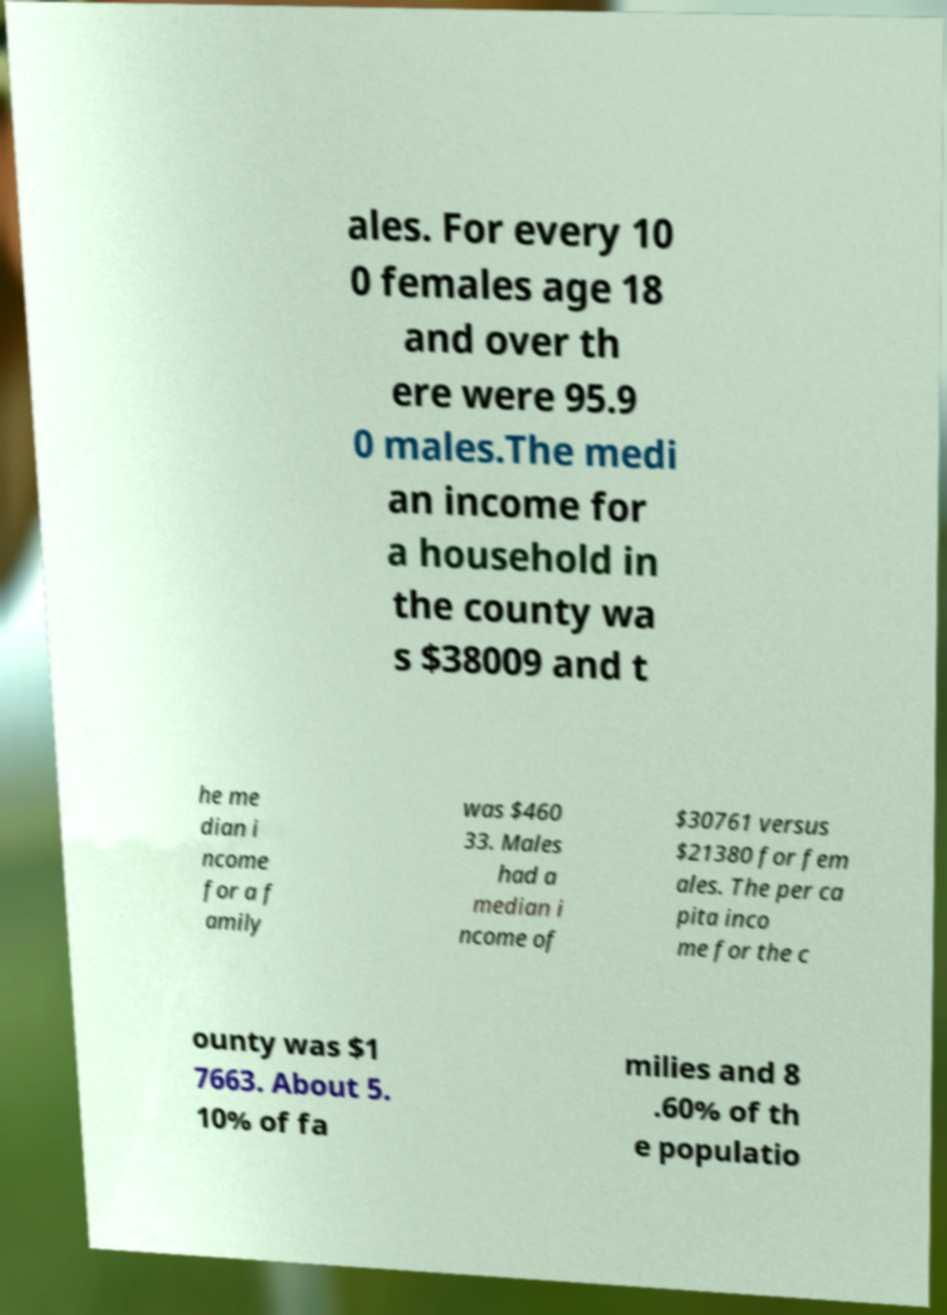Could you extract and type out the text from this image? ales. For every 10 0 females age 18 and over th ere were 95.9 0 males.The medi an income for a household in the county wa s $38009 and t he me dian i ncome for a f amily was $460 33. Males had a median i ncome of $30761 versus $21380 for fem ales. The per ca pita inco me for the c ounty was $1 7663. About 5. 10% of fa milies and 8 .60% of th e populatio 